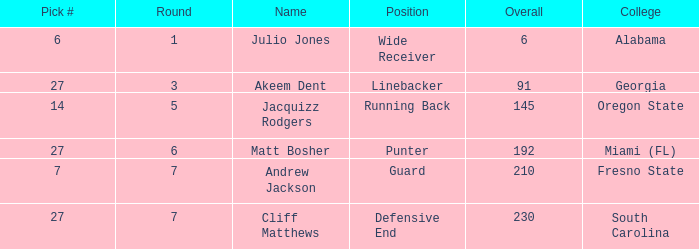Which highest pick number had Akeem Dent as a name and where the overall was less than 91? None. 